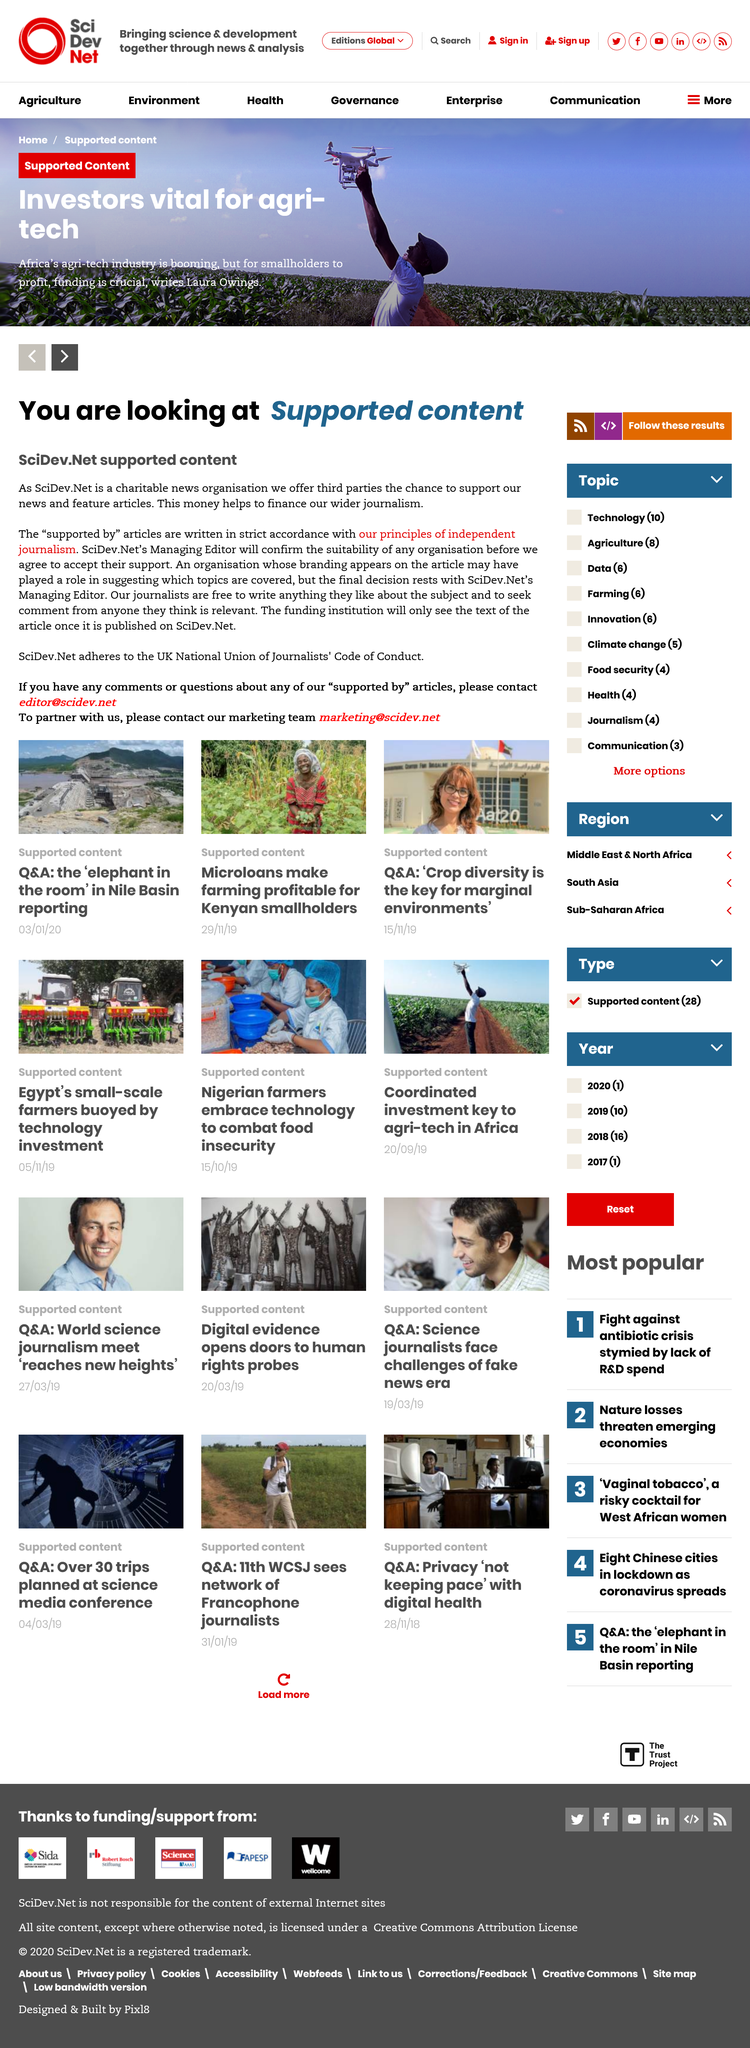Draw attention to some important aspects in this diagram. The SciDev journalists are free to write about any subject they choose and are not restricted in their writing. The funding institution will see the text of the article once it has been published. SciDev.Net is a supported content website that is financed by third parties. 